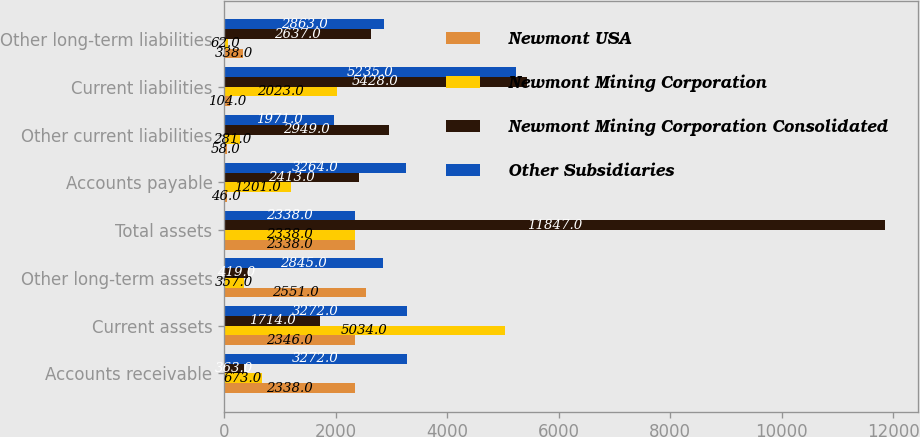Convert chart. <chart><loc_0><loc_0><loc_500><loc_500><stacked_bar_chart><ecel><fcel>Accounts receivable<fcel>Current assets<fcel>Other long-term assets<fcel>Total assets<fcel>Accounts payable<fcel>Other current liabilities<fcel>Current liabilities<fcel>Other long-term liabilities<nl><fcel>Newmont USA<fcel>2338<fcel>2346<fcel>2551<fcel>2338<fcel>46<fcel>58<fcel>104<fcel>338<nl><fcel>Newmont Mining Corporation<fcel>673<fcel>5034<fcel>357<fcel>2338<fcel>1201<fcel>281<fcel>2023<fcel>62<nl><fcel>Newmont Mining Corporation Consolidated<fcel>363<fcel>1714<fcel>419<fcel>11847<fcel>2413<fcel>2949<fcel>5428<fcel>2637<nl><fcel>Other Subsidiaries<fcel>3272<fcel>3272<fcel>2845<fcel>2338<fcel>3264<fcel>1971<fcel>5235<fcel>2863<nl></chart> 